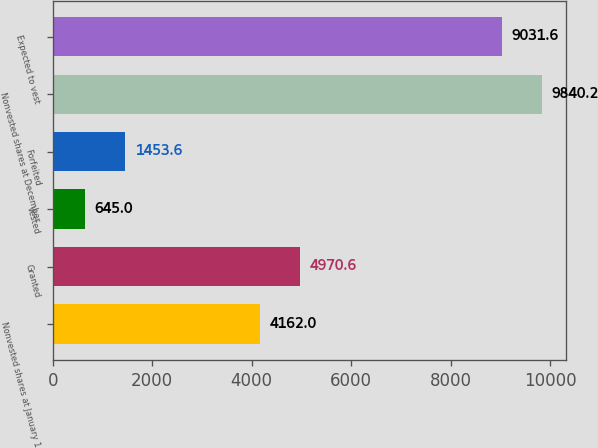Convert chart. <chart><loc_0><loc_0><loc_500><loc_500><bar_chart><fcel>Nonvested shares at January 1<fcel>Granted<fcel>Vested<fcel>Forfeited<fcel>Nonvested shares at December<fcel>Expected to vest<nl><fcel>4162<fcel>4970.6<fcel>645<fcel>1453.6<fcel>9840.2<fcel>9031.6<nl></chart> 